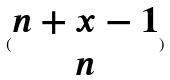<formula> <loc_0><loc_0><loc_500><loc_500>( \begin{matrix} n + x - 1 \\ n \end{matrix} )</formula> 